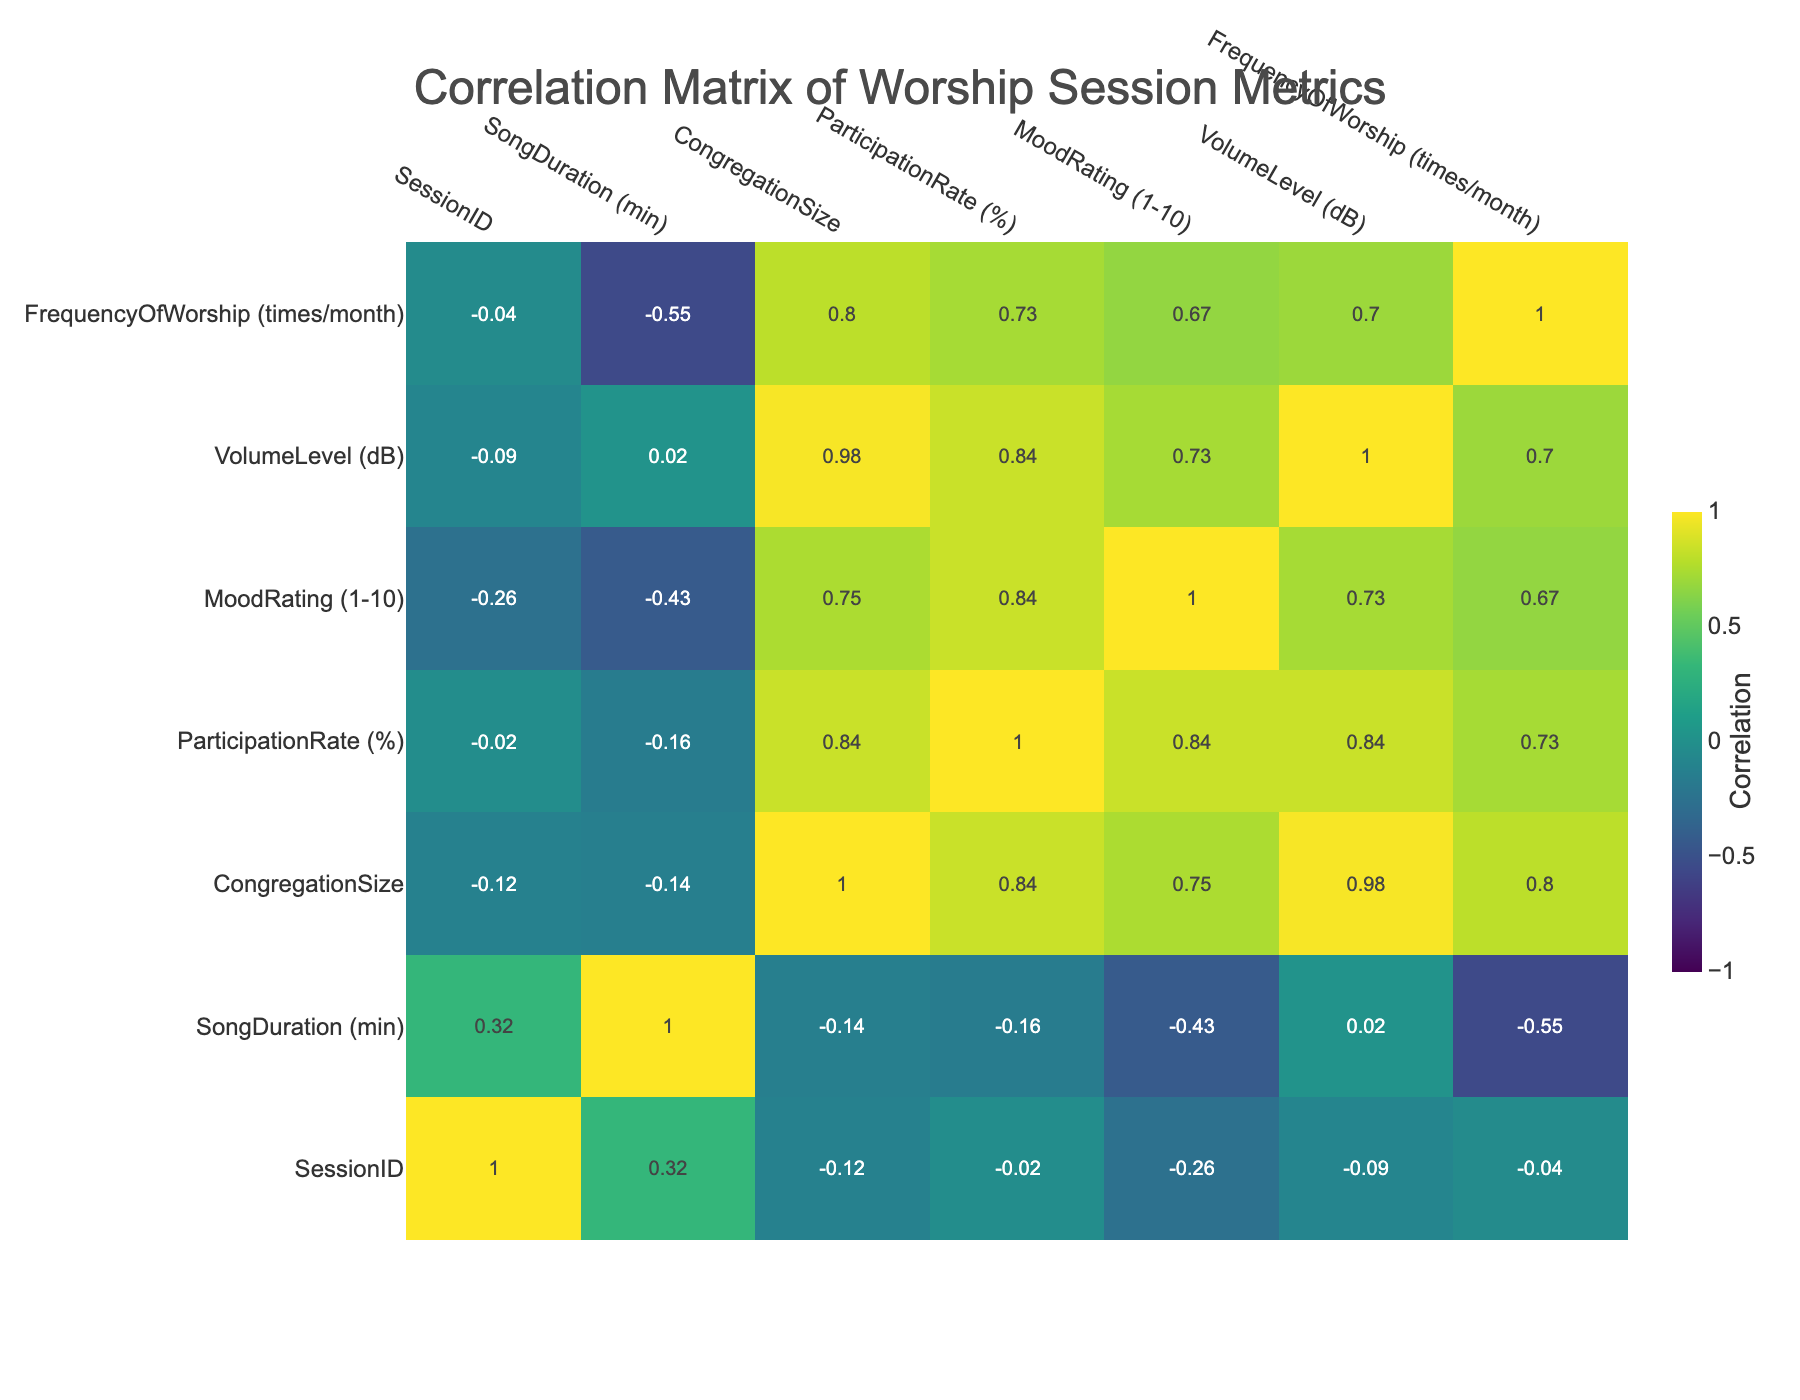What is the mood rating for the session with the smallest congregation size? The smallest congregation size is 100, which corresponds to Session 3. Looking at the table, the Mood Rating for Session 3 is 7.
Answer: 7 What is the participation rate for the session where the volume level was the highest? The highest volume level recorded is 85 dB, which corresponds to Session 4. The Participation Rate for Session 4 is 95%.
Answer: 95% Is the participation rate for sessions with a duration of 7 minutes or more higher than those with less than 7 minutes? The sessions with 7 minutes or more are Session 2 (90%), Session 4 (95%), Session 5 (80%), and Session 6 (88%). The average for these is (90 + 95 + 80 + 88) / 4 = 88.25%. The sessions with less than 7 minutes are Sessions 1 (85%), 3 (70%), 7 (75%), and 10 (80%), which average (85 + 70 + 75 + 80) / 4 = 77.5%. Since 88.25% is greater than 77.5%, the statement is true.
Answer: Yes What is the average song duration for sessions with a mood rating of 8 or higher? The sessions with a mood rating of 8 or higher are Session 2 (7 min), Session 4 (6 min), Session 6 (5 min), and Session 9 (6 min). The average duration is (7 + 6 + 5 + 6) / 4 = 6 min.
Answer: 6 min Got the highest volume level recorded across all sessions? The highest volume level is 85 dB in Session 4.
Answer: 85 dB Does the frequency of worship sessions correlate positively with the participation rate? To determine this, we check the correlation values in the table. The correlation between Frequency of Worship and Participation Rate is 0.32, which is a positive correlation.
Answer: Yes How many sessions had a participation rate above 85%? The sessions with a participation rate above 85% are Session 2 (90%), Session 4 (95%), Session 6 (88%), and Session 9 (92%). There are 4 such sessions in total.
Answer: 4 What is the average mood rating for sessions with below 80% participation rate? The sessions with below 80% participation rate are Session 3 (7) and Session 10 (7). The average is (7 + 7) / 2 = 7.
Answer: 7 What is the relationship between song duration and mood rating based on the correlation table? The correlation between Song Duration and Mood Rating is 0.39, indicating a positive relationship; longer song durations are associated with higher mood ratings.
Answer: Positive relationship 